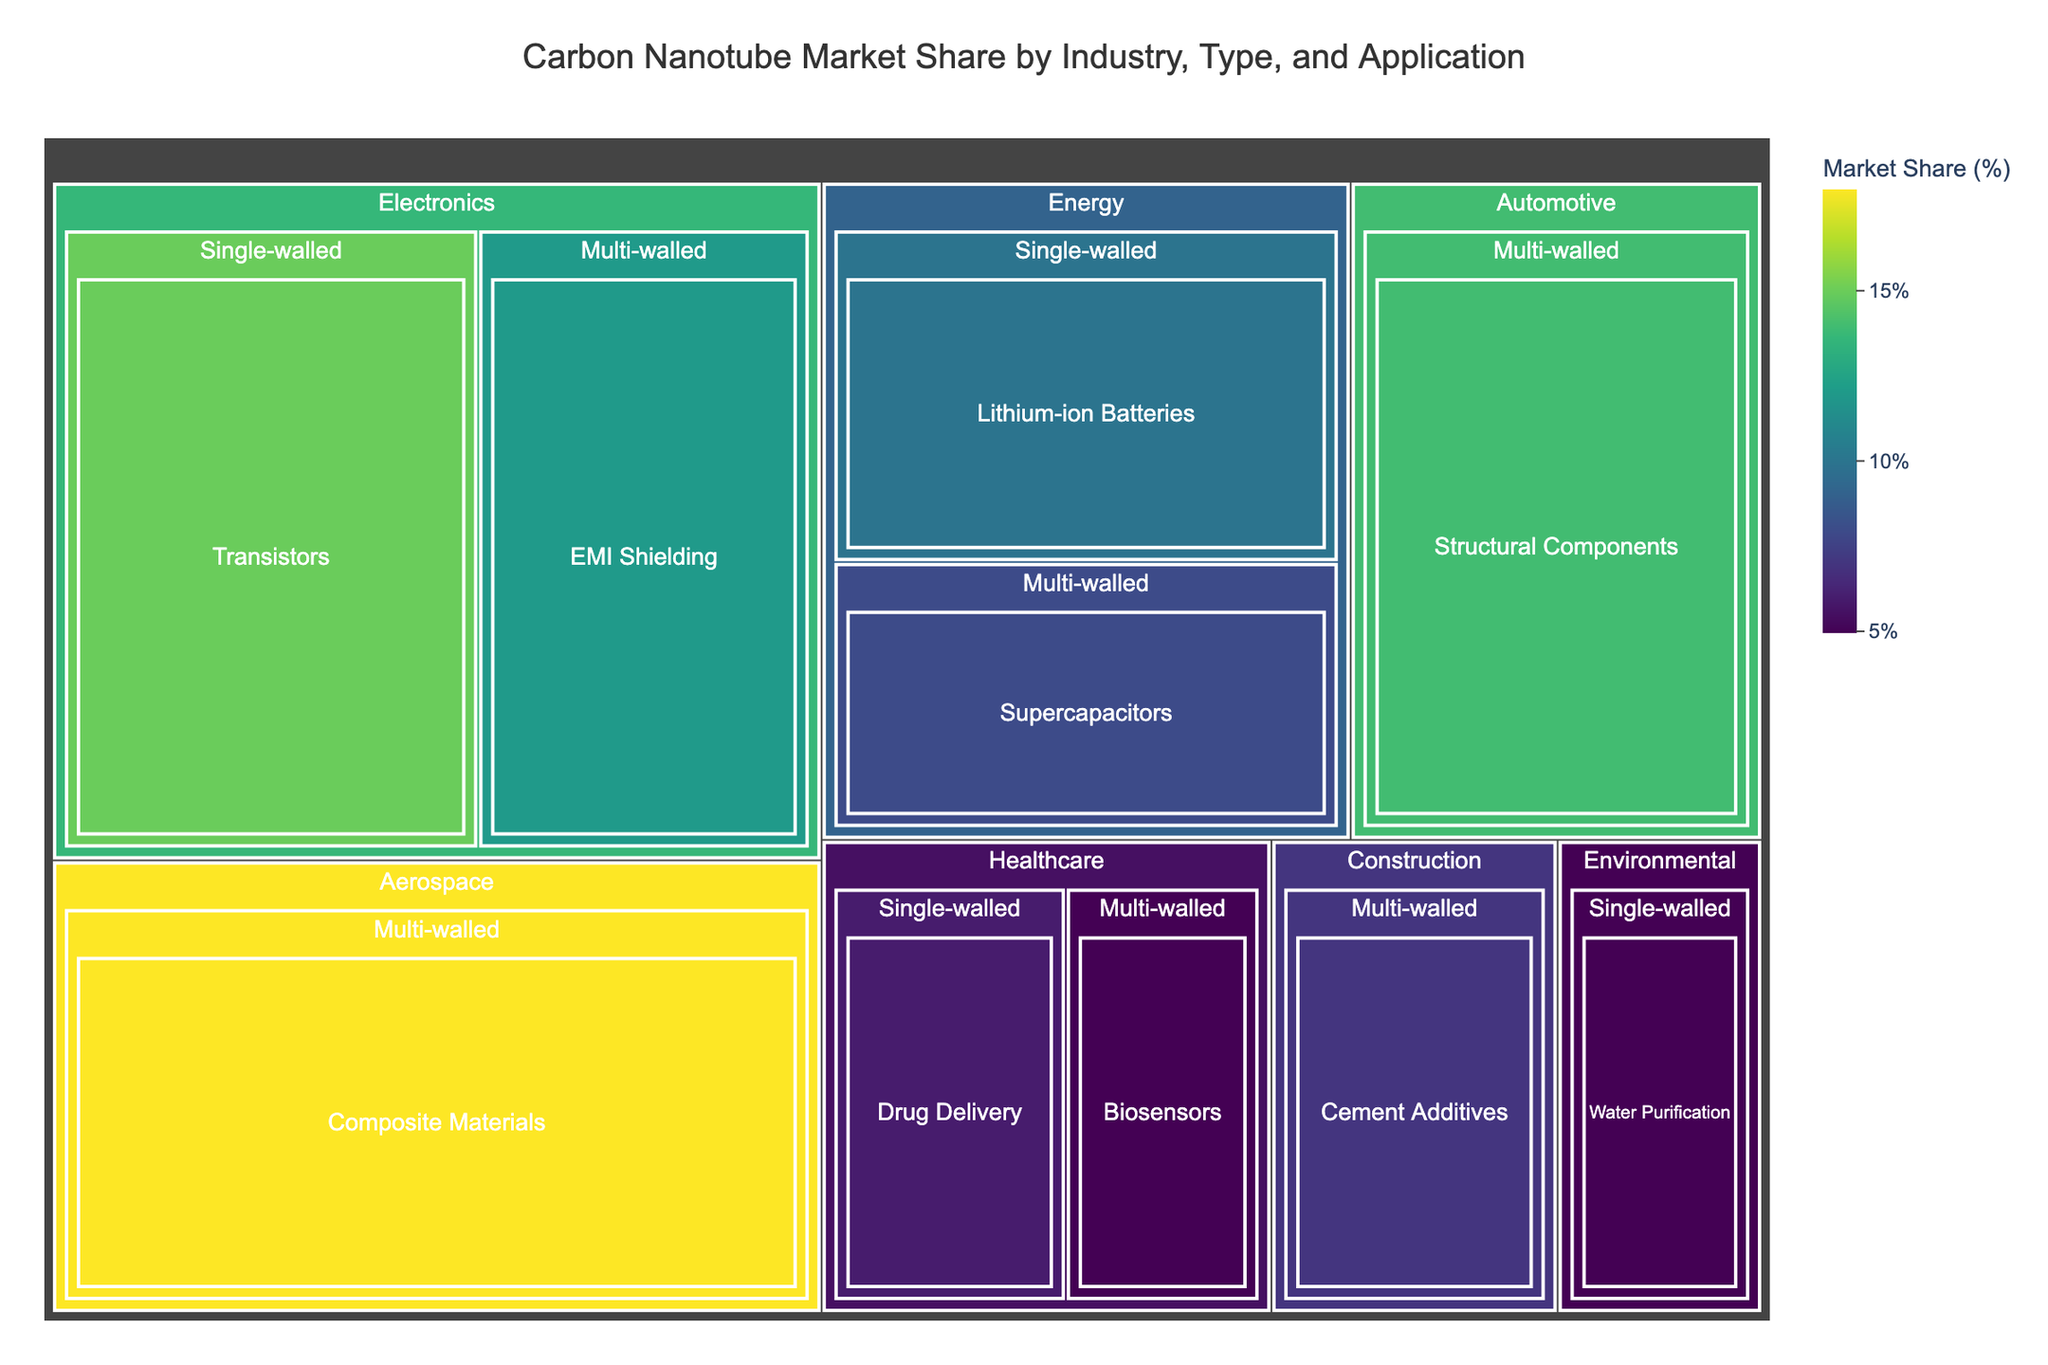What is the total market share of the Electronics industry? To find the total market share of the Electronics industry, add the market share of its components: Single-walled (Transistors, 15%) and Multi-walled (EMI Shielding, 12%).
Answer: 27% Which CNT type has the highest market share in the Automotive industry? The treemap indicates that only Multi-walled CNTs are used in the Automotive industry with a market share of 14%.
Answer: Multi-walled Compare the market shares of healthcare applications for Single-walled and Multi-walled CNTs. Which one is higher? Compare the market shares: Single-walled (Drug Delivery, 6%) and Multi-walled (Biosensors, 5%). Single-walled has a higher market share.
Answer: Single-walled By how much does the market share of multi-walled CNTs in the aerospace sector exceed that of the construction sector? Aerospace (Composite Materials, 18%) and Construction (Cement Additives, 7%). The difference is 18% - 7% = 11%.
Answer: 11% What's the average market share of the healthcare and environmental industries? Healthcare (Drug Delivery: 6%, Biosensors: 5%) combined is 11%. Environmental (Water Purification: 5%). Average = (11% + 5%) / 2 = 8%.
Answer: 8% What is the market share of Single-walled CNTs in the Energy industry? According to the treemap, Single-walled CNTs in the Energy industry (Lithium-ion Batteries) have a market share of 10%.
Answer: 10% Which industry has the largest total market share of Multi-walled CNTs? Compare the total market share of Multi-walled CNTs across all industries: Electronics (12%), Aerospace (18%), Energy (8%), Automotive (14%), Healthcare (5%), Construction (7%). Aerospace leads with 18%.
Answer: Aerospace How does the market share of single-walled CNTs in electronics compare to multi-walled CNTs in the same industry? The market share of Single-walled CNTs in electronics is 15%, and Multi-walled CNTs in electronics is 12%. Single-walled is 3% higher.
Answer: 3% What is the combined market share of all applications in the environmental and healthcare industries? Environmental (Water Purification: 5%), Healthcare (Drug Delivery: 6%, Biosensors: 5%). Combined, it's 5% + 6% + 5% = 16%.
Answer: 16% Which application has the lowest market share in the entire dataset? From the treemap, Biosensors in Healthcare (Multi-walled CNTs) has the lowest share at 5%.
Answer: Biosensors 